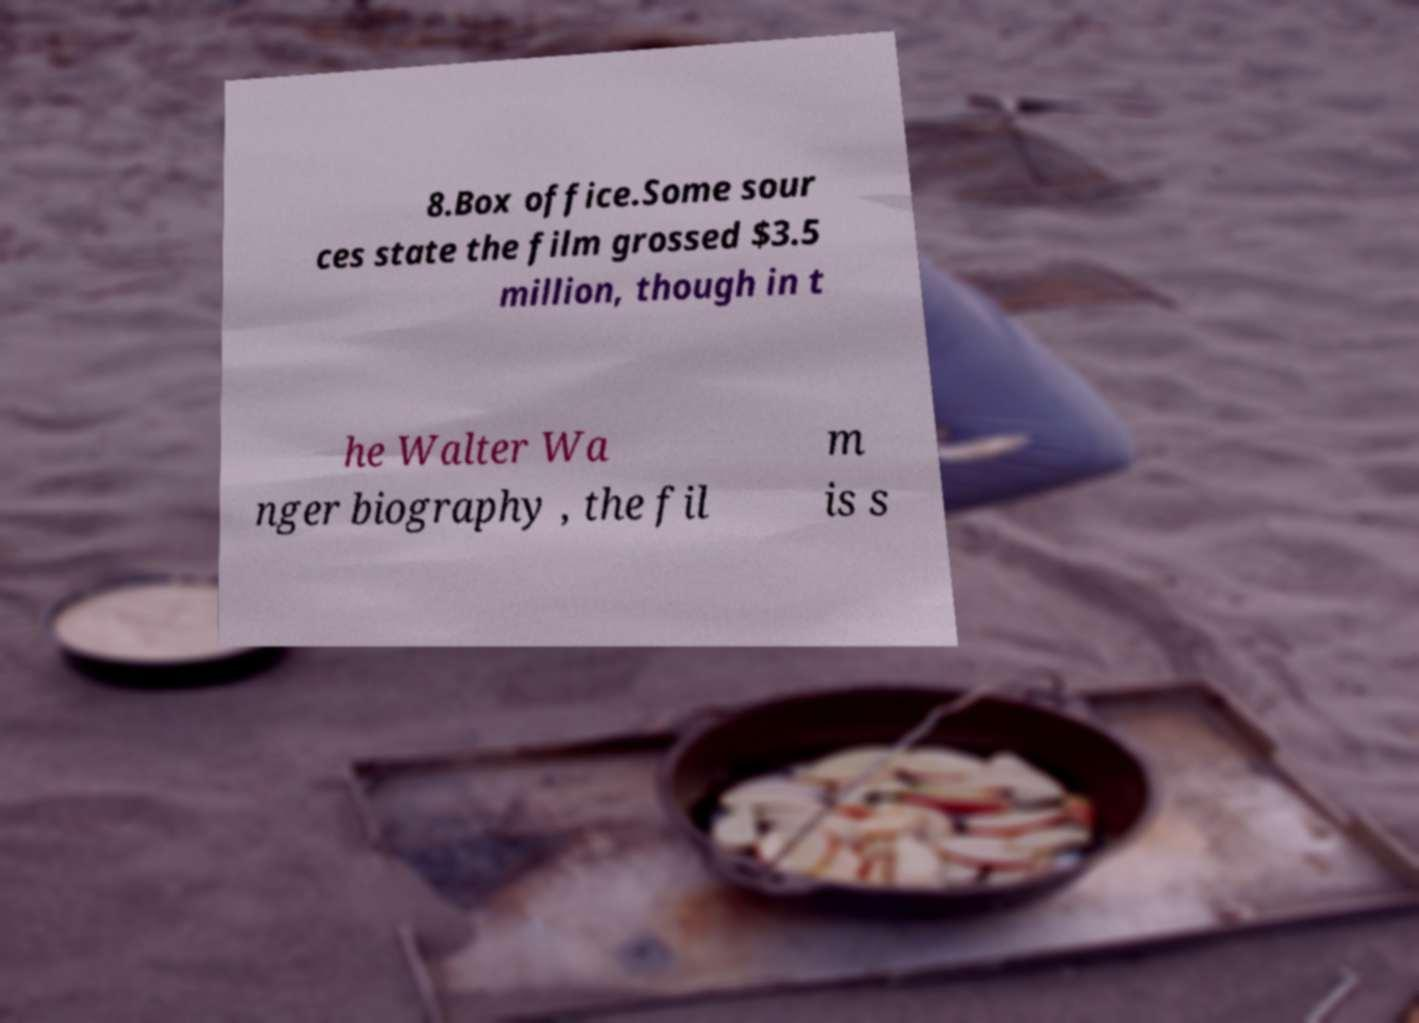Could you extract and type out the text from this image? 8.Box office.Some sour ces state the film grossed $3.5 million, though in t he Walter Wa nger biography , the fil m is s 